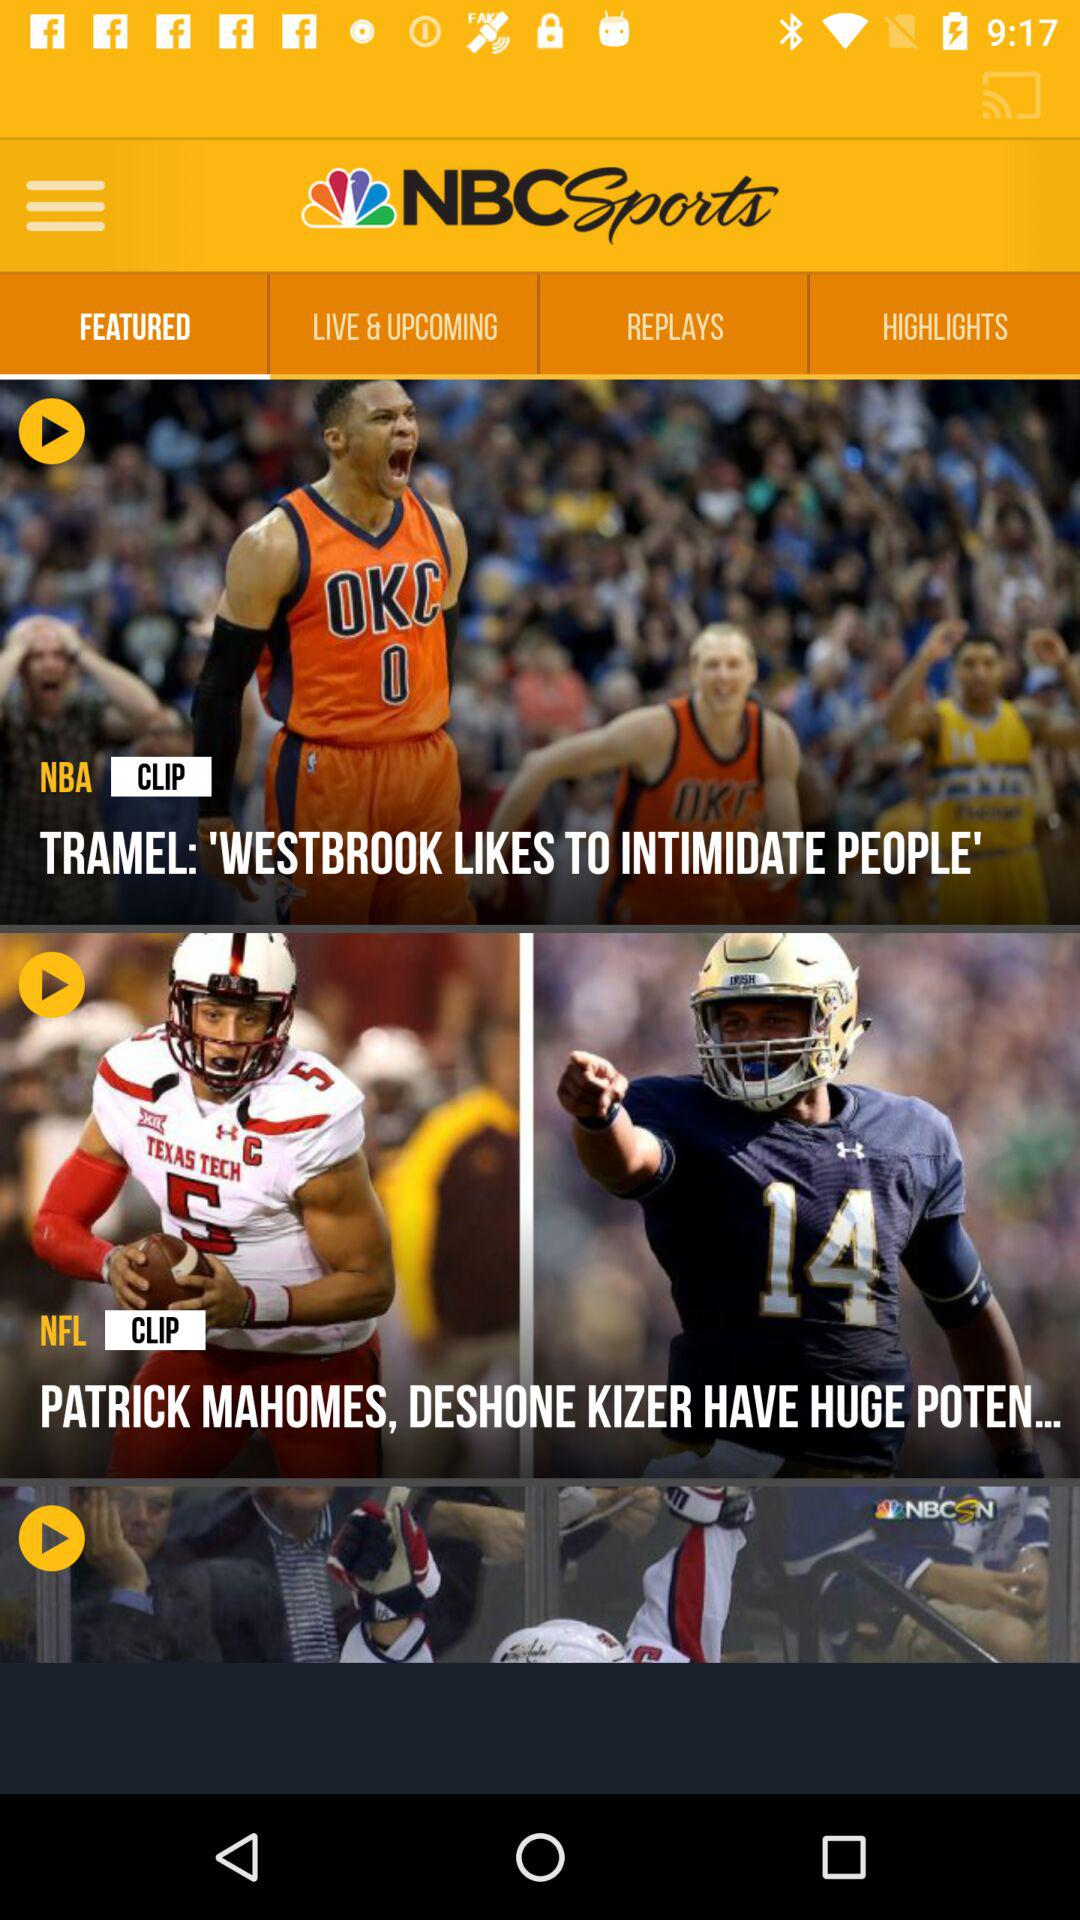Which tab is selected? The selected tab is "FEATURED". 